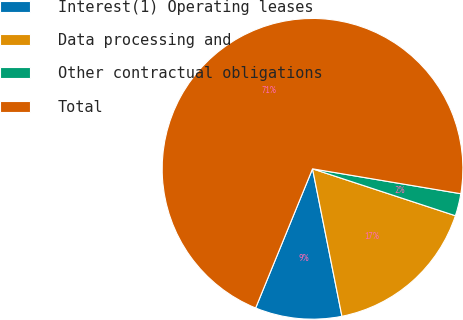Convert chart to OTSL. <chart><loc_0><loc_0><loc_500><loc_500><pie_chart><fcel>Interest(1) Operating leases<fcel>Data processing and<fcel>Other contractual obligations<fcel>Total<nl><fcel>9.31%<fcel>16.82%<fcel>2.4%<fcel>71.48%<nl></chart> 